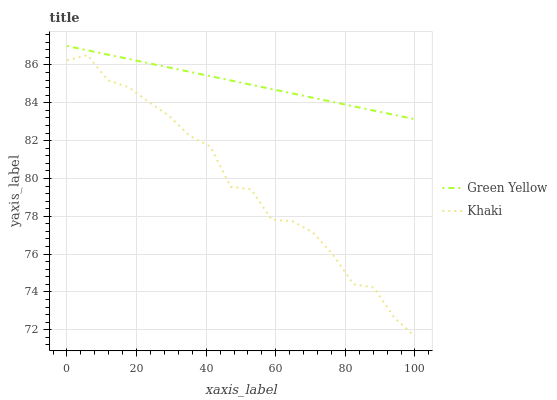Does Khaki have the maximum area under the curve?
Answer yes or no. No. Is Khaki the smoothest?
Answer yes or no. No. Does Khaki have the highest value?
Answer yes or no. No. Is Khaki less than Green Yellow?
Answer yes or no. Yes. Is Green Yellow greater than Khaki?
Answer yes or no. Yes. Does Khaki intersect Green Yellow?
Answer yes or no. No. 